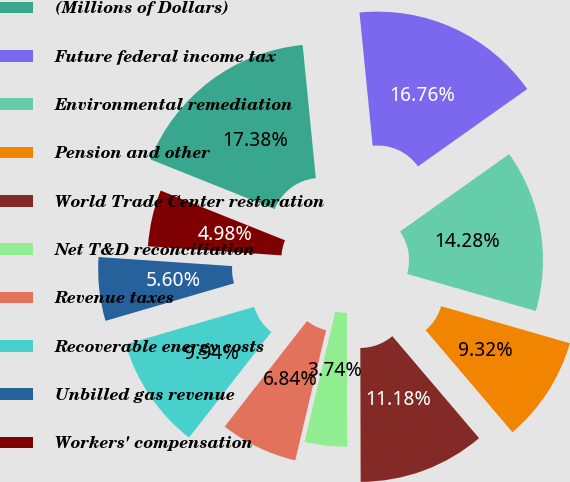Convert chart to OTSL. <chart><loc_0><loc_0><loc_500><loc_500><pie_chart><fcel>(Millions of Dollars)<fcel>Future federal income tax<fcel>Environmental remediation<fcel>Pension and other<fcel>World Trade Center restoration<fcel>Net T&D reconciliation<fcel>Revenue taxes<fcel>Recoverable energy costs<fcel>Unbilled gas revenue<fcel>Workers' compensation<nl><fcel>17.38%<fcel>16.76%<fcel>14.28%<fcel>9.32%<fcel>11.18%<fcel>3.74%<fcel>6.84%<fcel>9.94%<fcel>5.6%<fcel>4.98%<nl></chart> 